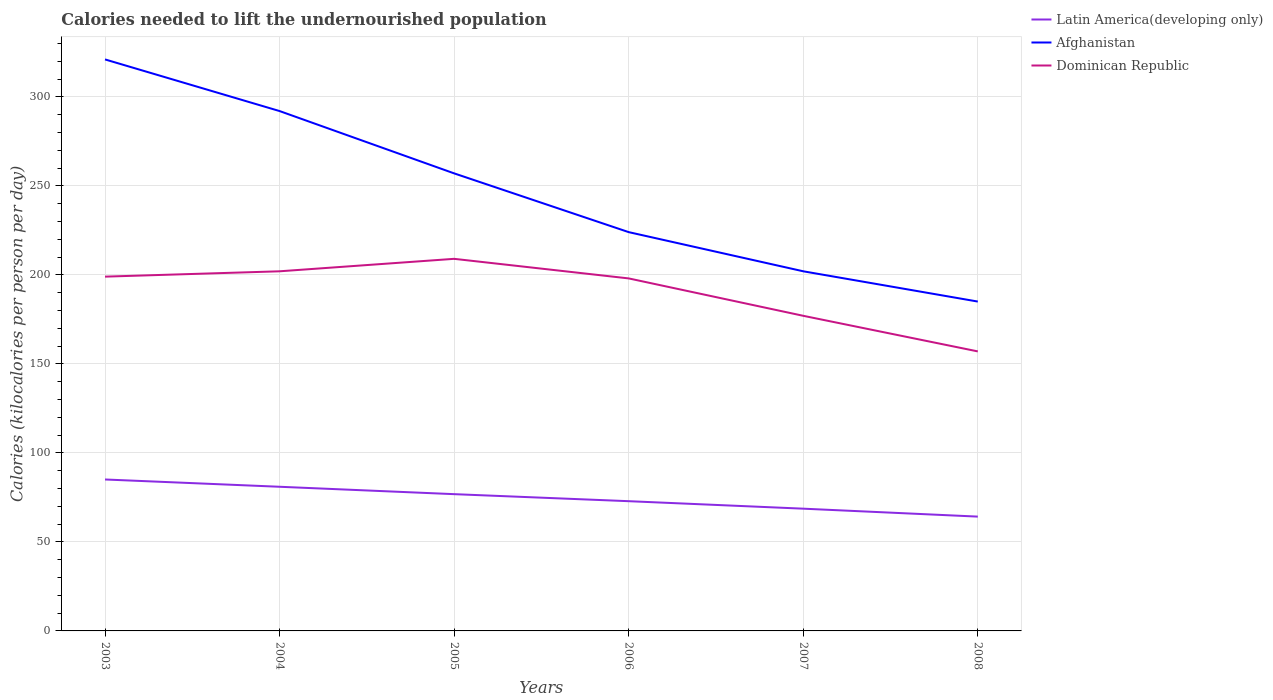Across all years, what is the maximum total calories needed to lift the undernourished population in Afghanistan?
Provide a short and direct response. 185. In which year was the total calories needed to lift the undernourished population in Latin America(developing only) maximum?
Ensure brevity in your answer.  2008. What is the total total calories needed to lift the undernourished population in Dominican Republic in the graph?
Make the answer very short. 1. What is the difference between the highest and the second highest total calories needed to lift the undernourished population in Latin America(developing only)?
Give a very brief answer. 20.85. Is the total calories needed to lift the undernourished population in Latin America(developing only) strictly greater than the total calories needed to lift the undernourished population in Dominican Republic over the years?
Provide a succinct answer. Yes. How many years are there in the graph?
Ensure brevity in your answer.  6. What is the difference between two consecutive major ticks on the Y-axis?
Give a very brief answer. 50. Does the graph contain any zero values?
Offer a terse response. No. Does the graph contain grids?
Give a very brief answer. Yes. How are the legend labels stacked?
Keep it short and to the point. Vertical. What is the title of the graph?
Provide a short and direct response. Calories needed to lift the undernourished population. Does "Cuba" appear as one of the legend labels in the graph?
Your answer should be compact. No. What is the label or title of the X-axis?
Ensure brevity in your answer.  Years. What is the label or title of the Y-axis?
Ensure brevity in your answer.  Calories (kilocalories per person per day). What is the Calories (kilocalories per person per day) of Latin America(developing only) in 2003?
Offer a very short reply. 85.06. What is the Calories (kilocalories per person per day) of Afghanistan in 2003?
Your answer should be very brief. 321. What is the Calories (kilocalories per person per day) in Dominican Republic in 2003?
Keep it short and to the point. 199. What is the Calories (kilocalories per person per day) of Latin America(developing only) in 2004?
Ensure brevity in your answer.  80.97. What is the Calories (kilocalories per person per day) of Afghanistan in 2004?
Make the answer very short. 292. What is the Calories (kilocalories per person per day) of Dominican Republic in 2004?
Provide a succinct answer. 202. What is the Calories (kilocalories per person per day) of Latin America(developing only) in 2005?
Offer a very short reply. 76.82. What is the Calories (kilocalories per person per day) in Afghanistan in 2005?
Keep it short and to the point. 257. What is the Calories (kilocalories per person per day) of Dominican Republic in 2005?
Your answer should be very brief. 209. What is the Calories (kilocalories per person per day) in Latin America(developing only) in 2006?
Provide a succinct answer. 72.87. What is the Calories (kilocalories per person per day) in Afghanistan in 2006?
Your answer should be compact. 224. What is the Calories (kilocalories per person per day) of Dominican Republic in 2006?
Your response must be concise. 198. What is the Calories (kilocalories per person per day) of Latin America(developing only) in 2007?
Make the answer very short. 68.66. What is the Calories (kilocalories per person per day) of Afghanistan in 2007?
Offer a very short reply. 202. What is the Calories (kilocalories per person per day) of Dominican Republic in 2007?
Keep it short and to the point. 177. What is the Calories (kilocalories per person per day) of Latin America(developing only) in 2008?
Provide a short and direct response. 64.21. What is the Calories (kilocalories per person per day) in Afghanistan in 2008?
Keep it short and to the point. 185. What is the Calories (kilocalories per person per day) in Dominican Republic in 2008?
Your answer should be compact. 157. Across all years, what is the maximum Calories (kilocalories per person per day) in Latin America(developing only)?
Keep it short and to the point. 85.06. Across all years, what is the maximum Calories (kilocalories per person per day) in Afghanistan?
Provide a succinct answer. 321. Across all years, what is the maximum Calories (kilocalories per person per day) in Dominican Republic?
Your answer should be compact. 209. Across all years, what is the minimum Calories (kilocalories per person per day) of Latin America(developing only)?
Offer a very short reply. 64.21. Across all years, what is the minimum Calories (kilocalories per person per day) of Afghanistan?
Your answer should be compact. 185. Across all years, what is the minimum Calories (kilocalories per person per day) of Dominican Republic?
Offer a very short reply. 157. What is the total Calories (kilocalories per person per day) of Latin America(developing only) in the graph?
Offer a terse response. 448.59. What is the total Calories (kilocalories per person per day) of Afghanistan in the graph?
Your answer should be compact. 1481. What is the total Calories (kilocalories per person per day) in Dominican Republic in the graph?
Your answer should be compact. 1142. What is the difference between the Calories (kilocalories per person per day) in Latin America(developing only) in 2003 and that in 2004?
Your answer should be compact. 4.09. What is the difference between the Calories (kilocalories per person per day) of Latin America(developing only) in 2003 and that in 2005?
Your answer should be very brief. 8.24. What is the difference between the Calories (kilocalories per person per day) of Afghanistan in 2003 and that in 2005?
Provide a succinct answer. 64. What is the difference between the Calories (kilocalories per person per day) in Latin America(developing only) in 2003 and that in 2006?
Ensure brevity in your answer.  12.19. What is the difference between the Calories (kilocalories per person per day) in Afghanistan in 2003 and that in 2006?
Offer a very short reply. 97. What is the difference between the Calories (kilocalories per person per day) of Latin America(developing only) in 2003 and that in 2007?
Provide a succinct answer. 16.39. What is the difference between the Calories (kilocalories per person per day) in Afghanistan in 2003 and that in 2007?
Ensure brevity in your answer.  119. What is the difference between the Calories (kilocalories per person per day) in Dominican Republic in 2003 and that in 2007?
Your answer should be compact. 22. What is the difference between the Calories (kilocalories per person per day) in Latin America(developing only) in 2003 and that in 2008?
Make the answer very short. 20.85. What is the difference between the Calories (kilocalories per person per day) of Afghanistan in 2003 and that in 2008?
Offer a terse response. 136. What is the difference between the Calories (kilocalories per person per day) of Latin America(developing only) in 2004 and that in 2005?
Offer a terse response. 4.15. What is the difference between the Calories (kilocalories per person per day) in Afghanistan in 2004 and that in 2005?
Ensure brevity in your answer.  35. What is the difference between the Calories (kilocalories per person per day) in Dominican Republic in 2004 and that in 2005?
Your answer should be very brief. -7. What is the difference between the Calories (kilocalories per person per day) of Latin America(developing only) in 2004 and that in 2006?
Provide a short and direct response. 8.1. What is the difference between the Calories (kilocalories per person per day) of Latin America(developing only) in 2004 and that in 2007?
Offer a terse response. 12.3. What is the difference between the Calories (kilocalories per person per day) in Afghanistan in 2004 and that in 2007?
Offer a terse response. 90. What is the difference between the Calories (kilocalories per person per day) of Dominican Republic in 2004 and that in 2007?
Give a very brief answer. 25. What is the difference between the Calories (kilocalories per person per day) of Latin America(developing only) in 2004 and that in 2008?
Make the answer very short. 16.76. What is the difference between the Calories (kilocalories per person per day) in Afghanistan in 2004 and that in 2008?
Make the answer very short. 107. What is the difference between the Calories (kilocalories per person per day) of Latin America(developing only) in 2005 and that in 2006?
Ensure brevity in your answer.  3.95. What is the difference between the Calories (kilocalories per person per day) of Afghanistan in 2005 and that in 2006?
Your answer should be compact. 33. What is the difference between the Calories (kilocalories per person per day) of Latin America(developing only) in 2005 and that in 2007?
Offer a terse response. 8.15. What is the difference between the Calories (kilocalories per person per day) of Latin America(developing only) in 2005 and that in 2008?
Ensure brevity in your answer.  12.61. What is the difference between the Calories (kilocalories per person per day) of Afghanistan in 2005 and that in 2008?
Your response must be concise. 72. What is the difference between the Calories (kilocalories per person per day) of Latin America(developing only) in 2006 and that in 2007?
Your answer should be compact. 4.21. What is the difference between the Calories (kilocalories per person per day) in Afghanistan in 2006 and that in 2007?
Keep it short and to the point. 22. What is the difference between the Calories (kilocalories per person per day) of Dominican Republic in 2006 and that in 2007?
Provide a succinct answer. 21. What is the difference between the Calories (kilocalories per person per day) of Latin America(developing only) in 2006 and that in 2008?
Provide a short and direct response. 8.67. What is the difference between the Calories (kilocalories per person per day) in Dominican Republic in 2006 and that in 2008?
Keep it short and to the point. 41. What is the difference between the Calories (kilocalories per person per day) in Latin America(developing only) in 2007 and that in 2008?
Offer a very short reply. 4.46. What is the difference between the Calories (kilocalories per person per day) of Latin America(developing only) in 2003 and the Calories (kilocalories per person per day) of Afghanistan in 2004?
Your answer should be very brief. -206.94. What is the difference between the Calories (kilocalories per person per day) in Latin America(developing only) in 2003 and the Calories (kilocalories per person per day) in Dominican Republic in 2004?
Offer a very short reply. -116.94. What is the difference between the Calories (kilocalories per person per day) in Afghanistan in 2003 and the Calories (kilocalories per person per day) in Dominican Republic in 2004?
Keep it short and to the point. 119. What is the difference between the Calories (kilocalories per person per day) in Latin America(developing only) in 2003 and the Calories (kilocalories per person per day) in Afghanistan in 2005?
Your answer should be compact. -171.94. What is the difference between the Calories (kilocalories per person per day) in Latin America(developing only) in 2003 and the Calories (kilocalories per person per day) in Dominican Republic in 2005?
Offer a terse response. -123.94. What is the difference between the Calories (kilocalories per person per day) of Afghanistan in 2003 and the Calories (kilocalories per person per day) of Dominican Republic in 2005?
Give a very brief answer. 112. What is the difference between the Calories (kilocalories per person per day) in Latin America(developing only) in 2003 and the Calories (kilocalories per person per day) in Afghanistan in 2006?
Provide a short and direct response. -138.94. What is the difference between the Calories (kilocalories per person per day) in Latin America(developing only) in 2003 and the Calories (kilocalories per person per day) in Dominican Republic in 2006?
Your response must be concise. -112.94. What is the difference between the Calories (kilocalories per person per day) of Afghanistan in 2003 and the Calories (kilocalories per person per day) of Dominican Republic in 2006?
Your response must be concise. 123. What is the difference between the Calories (kilocalories per person per day) of Latin America(developing only) in 2003 and the Calories (kilocalories per person per day) of Afghanistan in 2007?
Give a very brief answer. -116.94. What is the difference between the Calories (kilocalories per person per day) in Latin America(developing only) in 2003 and the Calories (kilocalories per person per day) in Dominican Republic in 2007?
Make the answer very short. -91.94. What is the difference between the Calories (kilocalories per person per day) of Afghanistan in 2003 and the Calories (kilocalories per person per day) of Dominican Republic in 2007?
Provide a short and direct response. 144. What is the difference between the Calories (kilocalories per person per day) of Latin America(developing only) in 2003 and the Calories (kilocalories per person per day) of Afghanistan in 2008?
Provide a short and direct response. -99.94. What is the difference between the Calories (kilocalories per person per day) of Latin America(developing only) in 2003 and the Calories (kilocalories per person per day) of Dominican Republic in 2008?
Provide a succinct answer. -71.94. What is the difference between the Calories (kilocalories per person per day) of Afghanistan in 2003 and the Calories (kilocalories per person per day) of Dominican Republic in 2008?
Ensure brevity in your answer.  164. What is the difference between the Calories (kilocalories per person per day) in Latin America(developing only) in 2004 and the Calories (kilocalories per person per day) in Afghanistan in 2005?
Ensure brevity in your answer.  -176.03. What is the difference between the Calories (kilocalories per person per day) of Latin America(developing only) in 2004 and the Calories (kilocalories per person per day) of Dominican Republic in 2005?
Give a very brief answer. -128.03. What is the difference between the Calories (kilocalories per person per day) in Latin America(developing only) in 2004 and the Calories (kilocalories per person per day) in Afghanistan in 2006?
Provide a short and direct response. -143.03. What is the difference between the Calories (kilocalories per person per day) in Latin America(developing only) in 2004 and the Calories (kilocalories per person per day) in Dominican Republic in 2006?
Your answer should be very brief. -117.03. What is the difference between the Calories (kilocalories per person per day) in Afghanistan in 2004 and the Calories (kilocalories per person per day) in Dominican Republic in 2006?
Offer a very short reply. 94. What is the difference between the Calories (kilocalories per person per day) of Latin America(developing only) in 2004 and the Calories (kilocalories per person per day) of Afghanistan in 2007?
Provide a short and direct response. -121.03. What is the difference between the Calories (kilocalories per person per day) of Latin America(developing only) in 2004 and the Calories (kilocalories per person per day) of Dominican Republic in 2007?
Keep it short and to the point. -96.03. What is the difference between the Calories (kilocalories per person per day) in Afghanistan in 2004 and the Calories (kilocalories per person per day) in Dominican Republic in 2007?
Your answer should be very brief. 115. What is the difference between the Calories (kilocalories per person per day) of Latin America(developing only) in 2004 and the Calories (kilocalories per person per day) of Afghanistan in 2008?
Ensure brevity in your answer.  -104.03. What is the difference between the Calories (kilocalories per person per day) of Latin America(developing only) in 2004 and the Calories (kilocalories per person per day) of Dominican Republic in 2008?
Offer a very short reply. -76.03. What is the difference between the Calories (kilocalories per person per day) of Afghanistan in 2004 and the Calories (kilocalories per person per day) of Dominican Republic in 2008?
Offer a very short reply. 135. What is the difference between the Calories (kilocalories per person per day) in Latin America(developing only) in 2005 and the Calories (kilocalories per person per day) in Afghanistan in 2006?
Keep it short and to the point. -147.18. What is the difference between the Calories (kilocalories per person per day) of Latin America(developing only) in 2005 and the Calories (kilocalories per person per day) of Dominican Republic in 2006?
Your answer should be very brief. -121.18. What is the difference between the Calories (kilocalories per person per day) in Latin America(developing only) in 2005 and the Calories (kilocalories per person per day) in Afghanistan in 2007?
Provide a short and direct response. -125.18. What is the difference between the Calories (kilocalories per person per day) in Latin America(developing only) in 2005 and the Calories (kilocalories per person per day) in Dominican Republic in 2007?
Give a very brief answer. -100.18. What is the difference between the Calories (kilocalories per person per day) in Latin America(developing only) in 2005 and the Calories (kilocalories per person per day) in Afghanistan in 2008?
Keep it short and to the point. -108.18. What is the difference between the Calories (kilocalories per person per day) of Latin America(developing only) in 2005 and the Calories (kilocalories per person per day) of Dominican Republic in 2008?
Your response must be concise. -80.18. What is the difference between the Calories (kilocalories per person per day) of Latin America(developing only) in 2006 and the Calories (kilocalories per person per day) of Afghanistan in 2007?
Make the answer very short. -129.13. What is the difference between the Calories (kilocalories per person per day) in Latin America(developing only) in 2006 and the Calories (kilocalories per person per day) in Dominican Republic in 2007?
Your response must be concise. -104.13. What is the difference between the Calories (kilocalories per person per day) in Afghanistan in 2006 and the Calories (kilocalories per person per day) in Dominican Republic in 2007?
Your response must be concise. 47. What is the difference between the Calories (kilocalories per person per day) of Latin America(developing only) in 2006 and the Calories (kilocalories per person per day) of Afghanistan in 2008?
Your response must be concise. -112.13. What is the difference between the Calories (kilocalories per person per day) in Latin America(developing only) in 2006 and the Calories (kilocalories per person per day) in Dominican Republic in 2008?
Keep it short and to the point. -84.13. What is the difference between the Calories (kilocalories per person per day) of Latin America(developing only) in 2007 and the Calories (kilocalories per person per day) of Afghanistan in 2008?
Your response must be concise. -116.34. What is the difference between the Calories (kilocalories per person per day) of Latin America(developing only) in 2007 and the Calories (kilocalories per person per day) of Dominican Republic in 2008?
Your response must be concise. -88.34. What is the average Calories (kilocalories per person per day) in Latin America(developing only) per year?
Your answer should be compact. 74.76. What is the average Calories (kilocalories per person per day) of Afghanistan per year?
Your answer should be very brief. 246.83. What is the average Calories (kilocalories per person per day) in Dominican Republic per year?
Keep it short and to the point. 190.33. In the year 2003, what is the difference between the Calories (kilocalories per person per day) of Latin America(developing only) and Calories (kilocalories per person per day) of Afghanistan?
Your response must be concise. -235.94. In the year 2003, what is the difference between the Calories (kilocalories per person per day) in Latin America(developing only) and Calories (kilocalories per person per day) in Dominican Republic?
Ensure brevity in your answer.  -113.94. In the year 2003, what is the difference between the Calories (kilocalories per person per day) of Afghanistan and Calories (kilocalories per person per day) of Dominican Republic?
Offer a very short reply. 122. In the year 2004, what is the difference between the Calories (kilocalories per person per day) of Latin America(developing only) and Calories (kilocalories per person per day) of Afghanistan?
Your response must be concise. -211.03. In the year 2004, what is the difference between the Calories (kilocalories per person per day) in Latin America(developing only) and Calories (kilocalories per person per day) in Dominican Republic?
Your answer should be very brief. -121.03. In the year 2004, what is the difference between the Calories (kilocalories per person per day) of Afghanistan and Calories (kilocalories per person per day) of Dominican Republic?
Your answer should be very brief. 90. In the year 2005, what is the difference between the Calories (kilocalories per person per day) of Latin America(developing only) and Calories (kilocalories per person per day) of Afghanistan?
Make the answer very short. -180.18. In the year 2005, what is the difference between the Calories (kilocalories per person per day) in Latin America(developing only) and Calories (kilocalories per person per day) in Dominican Republic?
Provide a short and direct response. -132.18. In the year 2006, what is the difference between the Calories (kilocalories per person per day) in Latin America(developing only) and Calories (kilocalories per person per day) in Afghanistan?
Ensure brevity in your answer.  -151.13. In the year 2006, what is the difference between the Calories (kilocalories per person per day) of Latin America(developing only) and Calories (kilocalories per person per day) of Dominican Republic?
Provide a short and direct response. -125.13. In the year 2007, what is the difference between the Calories (kilocalories per person per day) of Latin America(developing only) and Calories (kilocalories per person per day) of Afghanistan?
Offer a very short reply. -133.34. In the year 2007, what is the difference between the Calories (kilocalories per person per day) in Latin America(developing only) and Calories (kilocalories per person per day) in Dominican Republic?
Make the answer very short. -108.34. In the year 2008, what is the difference between the Calories (kilocalories per person per day) in Latin America(developing only) and Calories (kilocalories per person per day) in Afghanistan?
Give a very brief answer. -120.79. In the year 2008, what is the difference between the Calories (kilocalories per person per day) in Latin America(developing only) and Calories (kilocalories per person per day) in Dominican Republic?
Provide a short and direct response. -92.79. What is the ratio of the Calories (kilocalories per person per day) in Latin America(developing only) in 2003 to that in 2004?
Offer a very short reply. 1.05. What is the ratio of the Calories (kilocalories per person per day) of Afghanistan in 2003 to that in 2004?
Your answer should be very brief. 1.1. What is the ratio of the Calories (kilocalories per person per day) of Dominican Republic in 2003 to that in 2004?
Your answer should be compact. 0.99. What is the ratio of the Calories (kilocalories per person per day) of Latin America(developing only) in 2003 to that in 2005?
Keep it short and to the point. 1.11. What is the ratio of the Calories (kilocalories per person per day) of Afghanistan in 2003 to that in 2005?
Offer a terse response. 1.25. What is the ratio of the Calories (kilocalories per person per day) of Dominican Republic in 2003 to that in 2005?
Offer a very short reply. 0.95. What is the ratio of the Calories (kilocalories per person per day) of Latin America(developing only) in 2003 to that in 2006?
Your answer should be very brief. 1.17. What is the ratio of the Calories (kilocalories per person per day) of Afghanistan in 2003 to that in 2006?
Your response must be concise. 1.43. What is the ratio of the Calories (kilocalories per person per day) in Latin America(developing only) in 2003 to that in 2007?
Offer a terse response. 1.24. What is the ratio of the Calories (kilocalories per person per day) of Afghanistan in 2003 to that in 2007?
Make the answer very short. 1.59. What is the ratio of the Calories (kilocalories per person per day) in Dominican Republic in 2003 to that in 2007?
Offer a terse response. 1.12. What is the ratio of the Calories (kilocalories per person per day) in Latin America(developing only) in 2003 to that in 2008?
Offer a terse response. 1.32. What is the ratio of the Calories (kilocalories per person per day) of Afghanistan in 2003 to that in 2008?
Make the answer very short. 1.74. What is the ratio of the Calories (kilocalories per person per day) in Dominican Republic in 2003 to that in 2008?
Provide a short and direct response. 1.27. What is the ratio of the Calories (kilocalories per person per day) in Latin America(developing only) in 2004 to that in 2005?
Offer a terse response. 1.05. What is the ratio of the Calories (kilocalories per person per day) of Afghanistan in 2004 to that in 2005?
Your answer should be compact. 1.14. What is the ratio of the Calories (kilocalories per person per day) in Dominican Republic in 2004 to that in 2005?
Provide a short and direct response. 0.97. What is the ratio of the Calories (kilocalories per person per day) in Afghanistan in 2004 to that in 2006?
Make the answer very short. 1.3. What is the ratio of the Calories (kilocalories per person per day) in Dominican Republic in 2004 to that in 2006?
Ensure brevity in your answer.  1.02. What is the ratio of the Calories (kilocalories per person per day) of Latin America(developing only) in 2004 to that in 2007?
Offer a very short reply. 1.18. What is the ratio of the Calories (kilocalories per person per day) in Afghanistan in 2004 to that in 2007?
Offer a very short reply. 1.45. What is the ratio of the Calories (kilocalories per person per day) in Dominican Republic in 2004 to that in 2007?
Keep it short and to the point. 1.14. What is the ratio of the Calories (kilocalories per person per day) in Latin America(developing only) in 2004 to that in 2008?
Ensure brevity in your answer.  1.26. What is the ratio of the Calories (kilocalories per person per day) in Afghanistan in 2004 to that in 2008?
Give a very brief answer. 1.58. What is the ratio of the Calories (kilocalories per person per day) in Dominican Republic in 2004 to that in 2008?
Offer a very short reply. 1.29. What is the ratio of the Calories (kilocalories per person per day) of Latin America(developing only) in 2005 to that in 2006?
Provide a succinct answer. 1.05. What is the ratio of the Calories (kilocalories per person per day) of Afghanistan in 2005 to that in 2006?
Provide a short and direct response. 1.15. What is the ratio of the Calories (kilocalories per person per day) in Dominican Republic in 2005 to that in 2006?
Provide a short and direct response. 1.06. What is the ratio of the Calories (kilocalories per person per day) of Latin America(developing only) in 2005 to that in 2007?
Give a very brief answer. 1.12. What is the ratio of the Calories (kilocalories per person per day) of Afghanistan in 2005 to that in 2007?
Your answer should be compact. 1.27. What is the ratio of the Calories (kilocalories per person per day) of Dominican Republic in 2005 to that in 2007?
Make the answer very short. 1.18. What is the ratio of the Calories (kilocalories per person per day) of Latin America(developing only) in 2005 to that in 2008?
Provide a succinct answer. 1.2. What is the ratio of the Calories (kilocalories per person per day) in Afghanistan in 2005 to that in 2008?
Provide a succinct answer. 1.39. What is the ratio of the Calories (kilocalories per person per day) of Dominican Republic in 2005 to that in 2008?
Your response must be concise. 1.33. What is the ratio of the Calories (kilocalories per person per day) in Latin America(developing only) in 2006 to that in 2007?
Your answer should be compact. 1.06. What is the ratio of the Calories (kilocalories per person per day) of Afghanistan in 2006 to that in 2007?
Provide a short and direct response. 1.11. What is the ratio of the Calories (kilocalories per person per day) in Dominican Republic in 2006 to that in 2007?
Make the answer very short. 1.12. What is the ratio of the Calories (kilocalories per person per day) in Latin America(developing only) in 2006 to that in 2008?
Make the answer very short. 1.14. What is the ratio of the Calories (kilocalories per person per day) of Afghanistan in 2006 to that in 2008?
Offer a terse response. 1.21. What is the ratio of the Calories (kilocalories per person per day) in Dominican Republic in 2006 to that in 2008?
Provide a short and direct response. 1.26. What is the ratio of the Calories (kilocalories per person per day) of Latin America(developing only) in 2007 to that in 2008?
Your response must be concise. 1.07. What is the ratio of the Calories (kilocalories per person per day) of Afghanistan in 2007 to that in 2008?
Ensure brevity in your answer.  1.09. What is the ratio of the Calories (kilocalories per person per day) in Dominican Republic in 2007 to that in 2008?
Ensure brevity in your answer.  1.13. What is the difference between the highest and the second highest Calories (kilocalories per person per day) of Latin America(developing only)?
Your response must be concise. 4.09. What is the difference between the highest and the second highest Calories (kilocalories per person per day) of Dominican Republic?
Provide a succinct answer. 7. What is the difference between the highest and the lowest Calories (kilocalories per person per day) in Latin America(developing only)?
Your answer should be very brief. 20.85. What is the difference between the highest and the lowest Calories (kilocalories per person per day) of Afghanistan?
Provide a succinct answer. 136. 